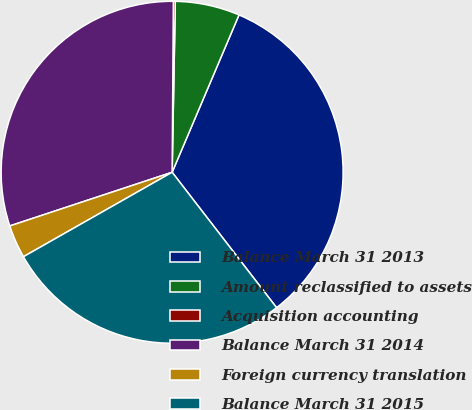<chart> <loc_0><loc_0><loc_500><loc_500><pie_chart><fcel>Balance March 31 2013<fcel>Amount reclassified to assets<fcel>Acquisition accounting<fcel>Balance March 31 2014<fcel>Foreign currency translation<fcel>Balance March 31 2015<nl><fcel>33.15%<fcel>6.1%<fcel>0.18%<fcel>30.2%<fcel>3.14%<fcel>27.24%<nl></chart> 